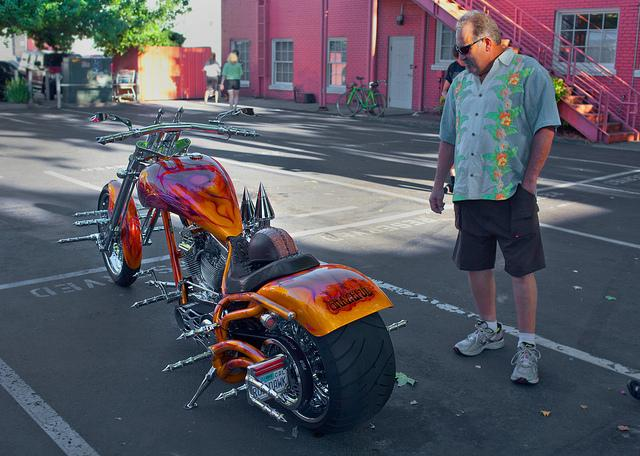How was this type of bike made?

Choices:
A) trade
B) custom
C) retail
D) assembly line custom 